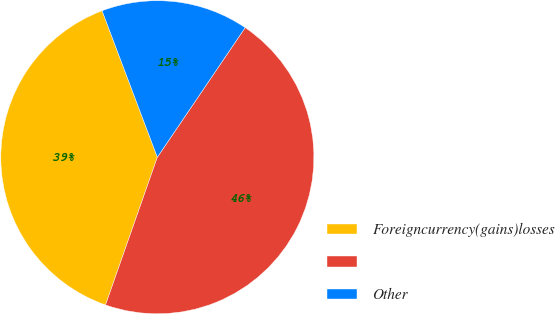Convert chart to OTSL. <chart><loc_0><loc_0><loc_500><loc_500><pie_chart><fcel>Foreigncurrency(gains)losses<fcel>Unnamed: 1<fcel>Other<nl><fcel>38.89%<fcel>45.89%<fcel>15.22%<nl></chart> 